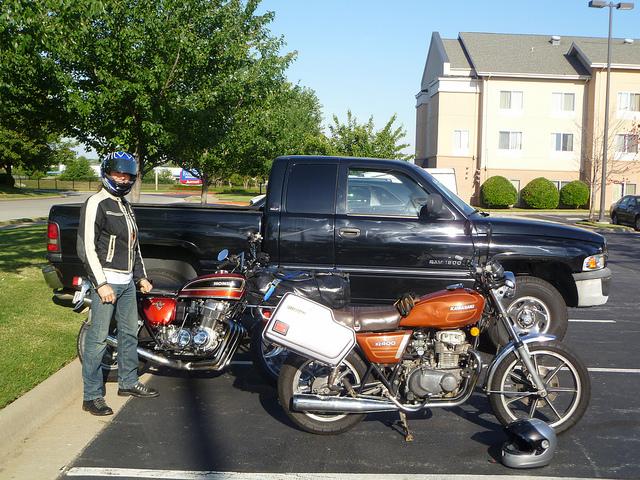Is this bike red?
Answer briefly. Yes. Is that a single dwelling residence?
Keep it brief. No. How many red motorcycles?
Short answer required. 1. Do both riders have helmets to wear?
Write a very short answer. Yes. Was this taken in the woods?
Answer briefly. No. What color is the seat of the foremost bike?
Be succinct. Brown. Is the person looking at the road?
Short answer required. No. 